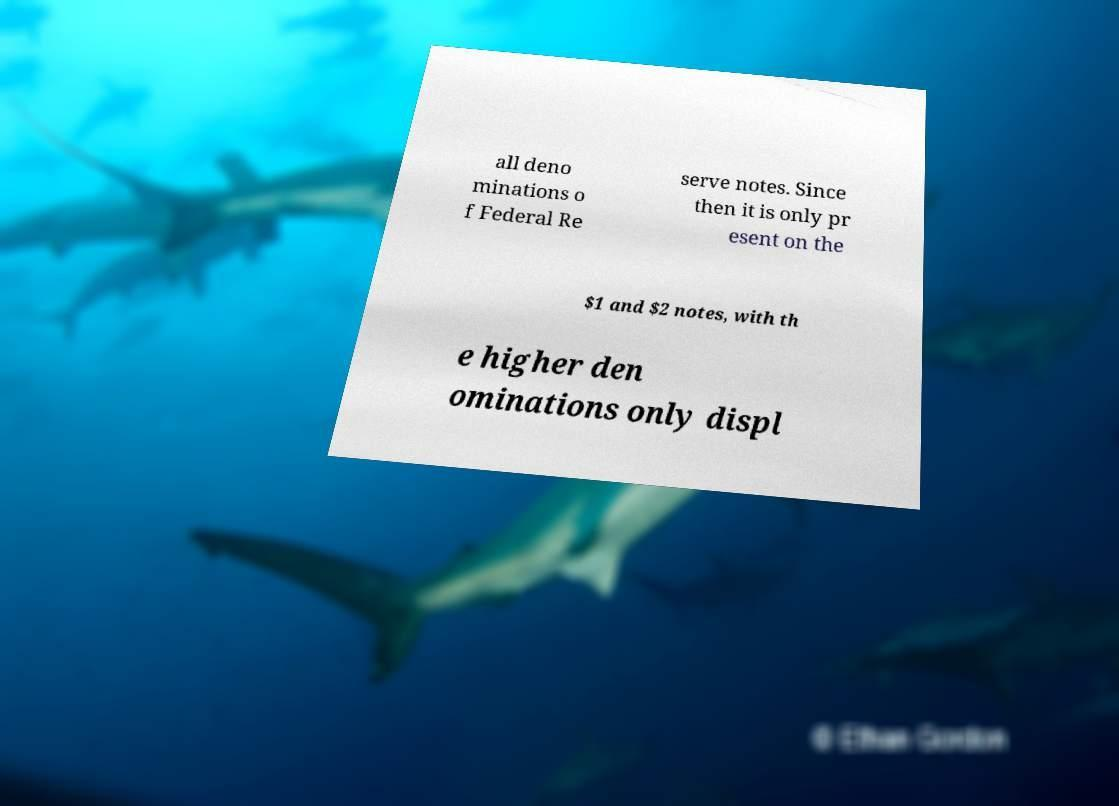Please identify and transcribe the text found in this image. all deno minations o f Federal Re serve notes. Since then it is only pr esent on the $1 and $2 notes, with th e higher den ominations only displ 